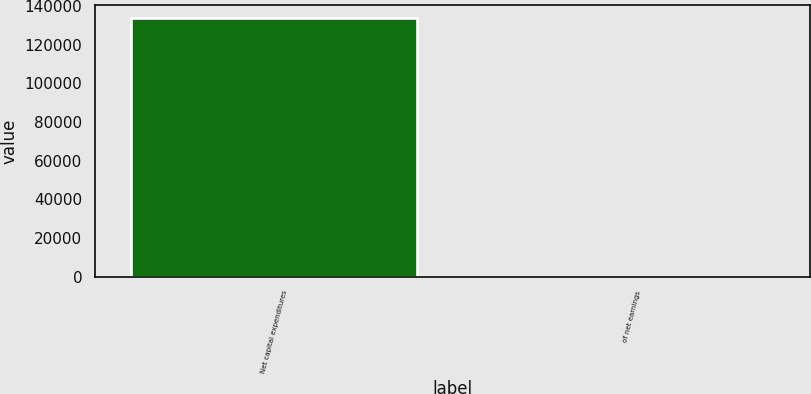Convert chart. <chart><loc_0><loc_0><loc_500><loc_500><bar_chart><fcel>Net capital expenditures<fcel>of net earnings<nl><fcel>133882<fcel>31.8<nl></chart> 